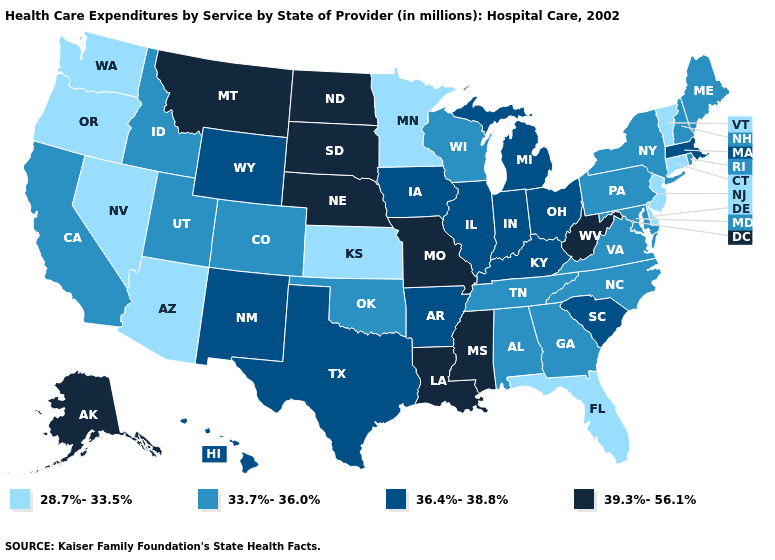Does New Hampshire have the same value as Utah?
Quick response, please. Yes. What is the lowest value in the USA?
Keep it brief. 28.7%-33.5%. What is the highest value in states that border Missouri?
Quick response, please. 39.3%-56.1%. Does Illinois have the lowest value in the USA?
Short answer required. No. Among the states that border South Dakota , does Montana have the lowest value?
Keep it brief. No. What is the value of Georgia?
Answer briefly. 33.7%-36.0%. What is the value of California?
Short answer required. 33.7%-36.0%. Among the states that border Colorado , which have the highest value?
Write a very short answer. Nebraska. Name the states that have a value in the range 36.4%-38.8%?
Short answer required. Arkansas, Hawaii, Illinois, Indiana, Iowa, Kentucky, Massachusetts, Michigan, New Mexico, Ohio, South Carolina, Texas, Wyoming. Does Kentucky have the highest value in the USA?
Be succinct. No. What is the lowest value in the USA?
Short answer required. 28.7%-33.5%. What is the value of New Jersey?
Write a very short answer. 28.7%-33.5%. Among the states that border Alabama , does Florida have the highest value?
Concise answer only. No. Does New Jersey have the lowest value in the Northeast?
Be succinct. Yes. What is the lowest value in the USA?
Answer briefly. 28.7%-33.5%. 